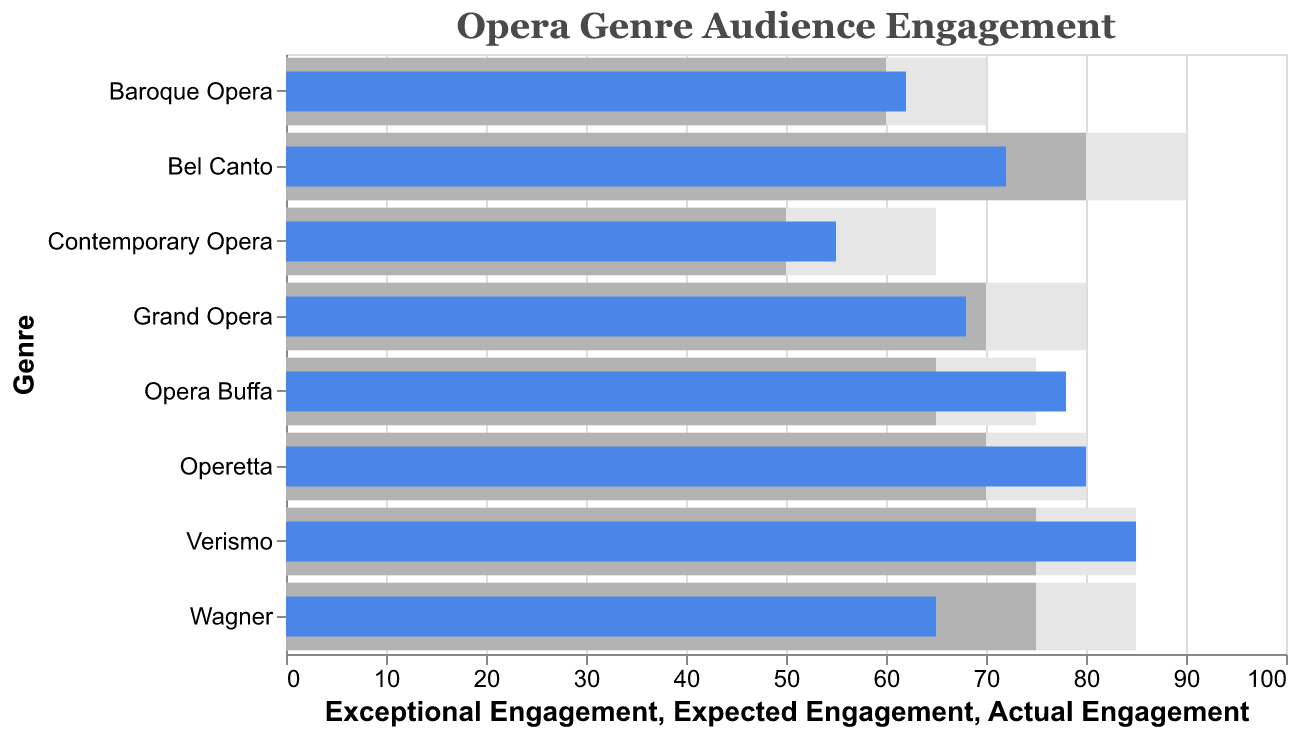What is the title of the chart? The title is typically displayed at the top of the chart. Here, it reads "Opera Genre Audience Engagement".
Answer: Opera Genre Audience Engagement Which opera genre had the highest actual engagement? By examining the bar representing "Actual Engagement," we see that "Verismo" has the highest actual engagement at 85.
Answer: Verismo Which genre had the lowest expected engagement? Comparing all the expected engagement bars, "Contemporary Opera" has the lowest expected engagement at 50.
Answer: Contemporary Opera How does the actual engagement of "Operetta" compare to its expected engagement? For "Operetta," the actual engagement is 80, while the expected engagement is 70. We can see that the actual engagement is 10 units higher than the expected engagement.
Answer: 10 units higher What is the difference between the exceptional engagement and actual engagement for "Opera Buffa"? The exceptional engagement for "Opera Buffa" is 75 and the actual engagement is 78. The difference is 78 - 75 = 3.
Answer: 3 For which genre is the actual engagement equal to the exceptional engagement? Looking at the bars, for "Verismo" the actual engagement (85) equals the exceptional engagement (85).
Answer: Verismo Compare the actual engagement of "Wagner" and "Grand Opera." Which one is higher and by how much? "Wagner" has an actual engagement of 65 and "Grand Opera" has 68. The actual engagement for "Grand Opera" is higher by 68 - 65 = 3 units.
Answer: Grand Opera by 3 units Is there any genre where all three engagement metrics (actual, expected, exceptional) are equal? By inspecting all genres, none have all three metrics (actual, expected, exceptional) equal.
Answer: No What is the average actual engagement across all genres? Sum all actual engagements: 72 + 85 + 68 + 78 + 62 + 55 + 80 + 65 = 565. There are 8 genres, so the average is 565 / 8 = 70.625.
Answer: 70.625 Which genre has the biggest difference between expected and exceptional engagement? For each genre, calculate the difference between expected and exceptional engagement. By comparison, "Contemporary Opera" has the biggest difference: 65 - 50 = 15.
Answer: Contemporary Opera 